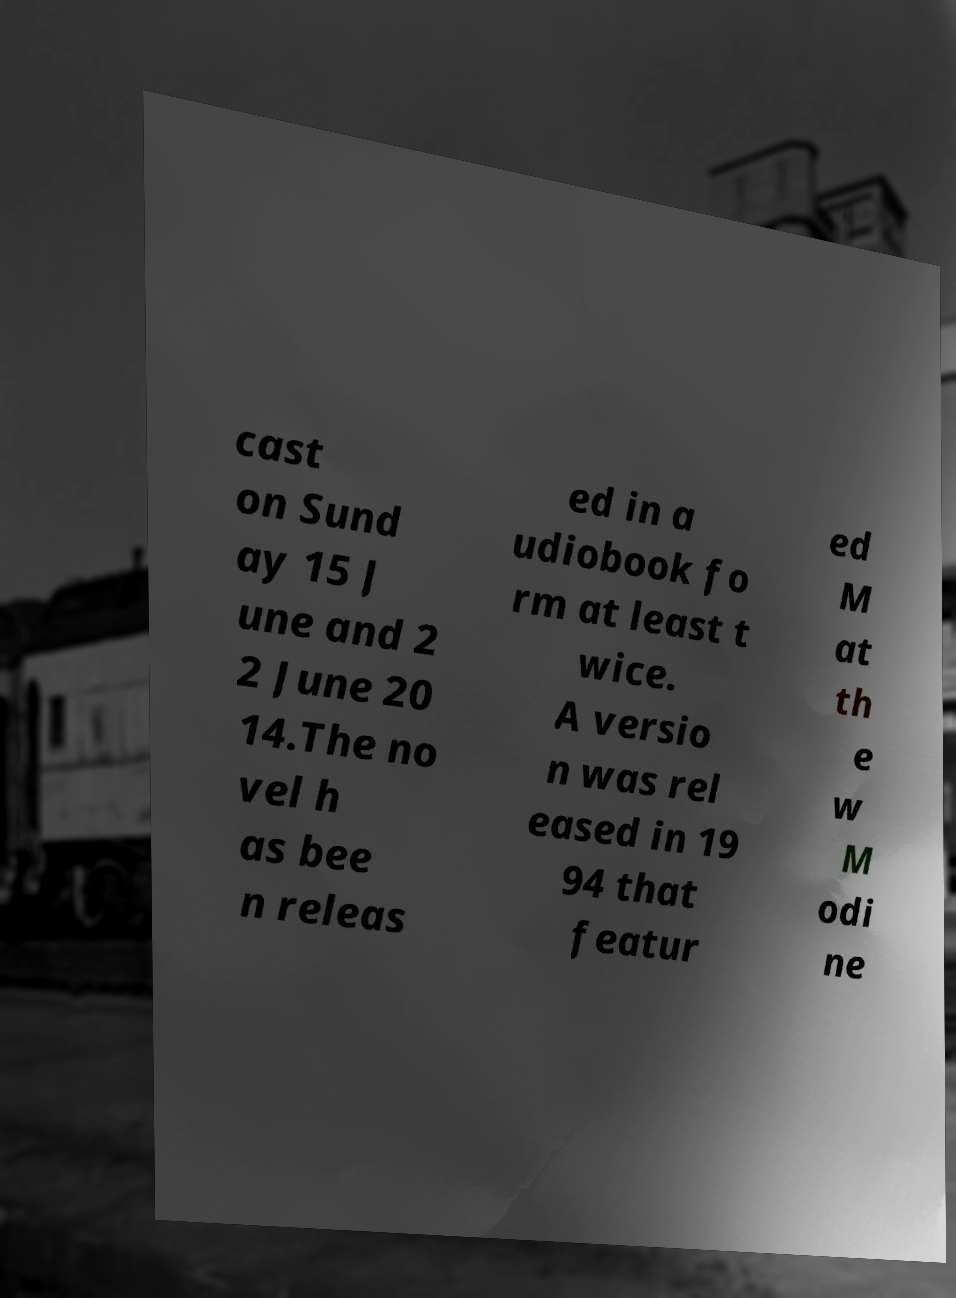Can you accurately transcribe the text from the provided image for me? cast on Sund ay 15 J une and 2 2 June 20 14.The no vel h as bee n releas ed in a udiobook fo rm at least t wice. A versio n was rel eased in 19 94 that featur ed M at th e w M odi ne 